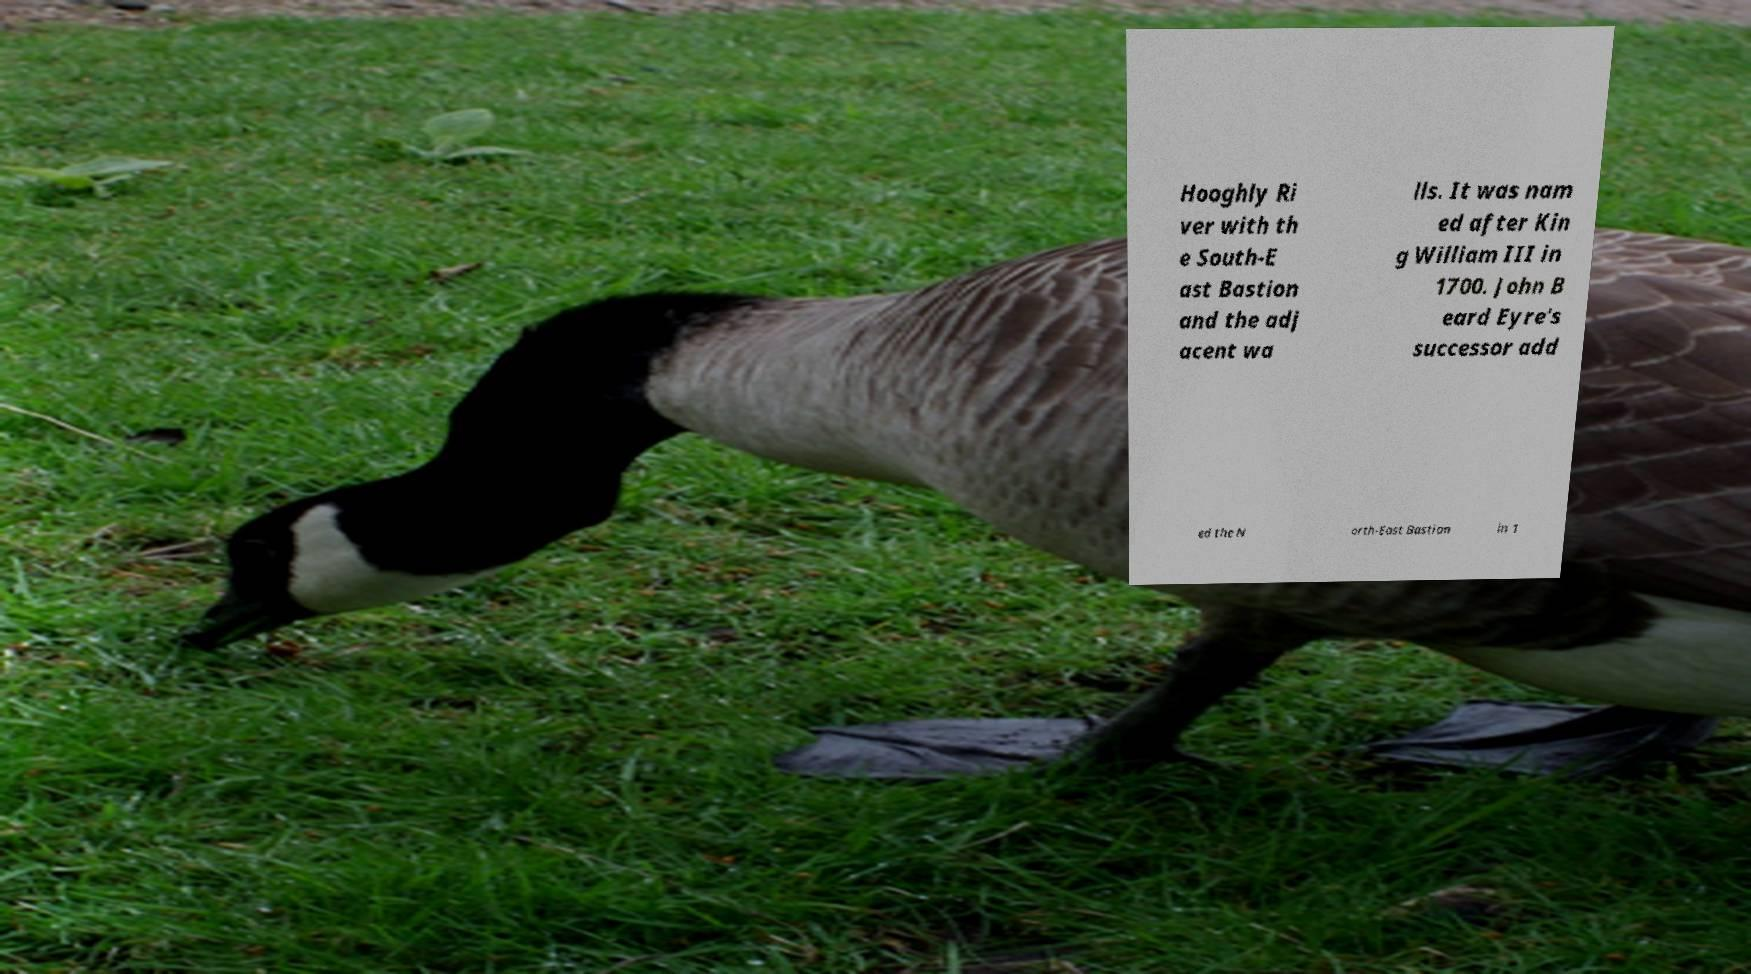Could you assist in decoding the text presented in this image and type it out clearly? Hooghly Ri ver with th e South-E ast Bastion and the adj acent wa lls. It was nam ed after Kin g William III in 1700. John B eard Eyre's successor add ed the N orth-East Bastion in 1 